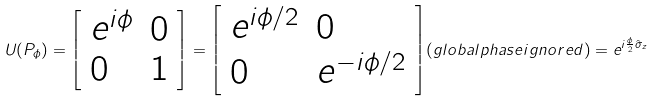<formula> <loc_0><loc_0><loc_500><loc_500>U ( P _ { \phi } ) = { \left [ \begin{array} { l l } { e ^ { i \phi } } & { 0 } \\ { 0 } & { 1 } \end{array} \right ] } = { \left [ \begin{array} { l l } { e ^ { i \phi / 2 } } & { 0 } \\ { 0 } & { e ^ { - i \phi / 2 } } \end{array} \right ] } { ( g l o b a l p h a s e i g n o r e d ) } = e ^ { i { \frac { \phi } { 2 } } { \hat { \sigma } } _ { z } }</formula> 